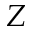Convert formula to latex. <formula><loc_0><loc_0><loc_500><loc_500>Z</formula> 